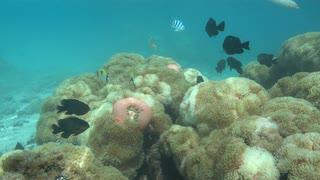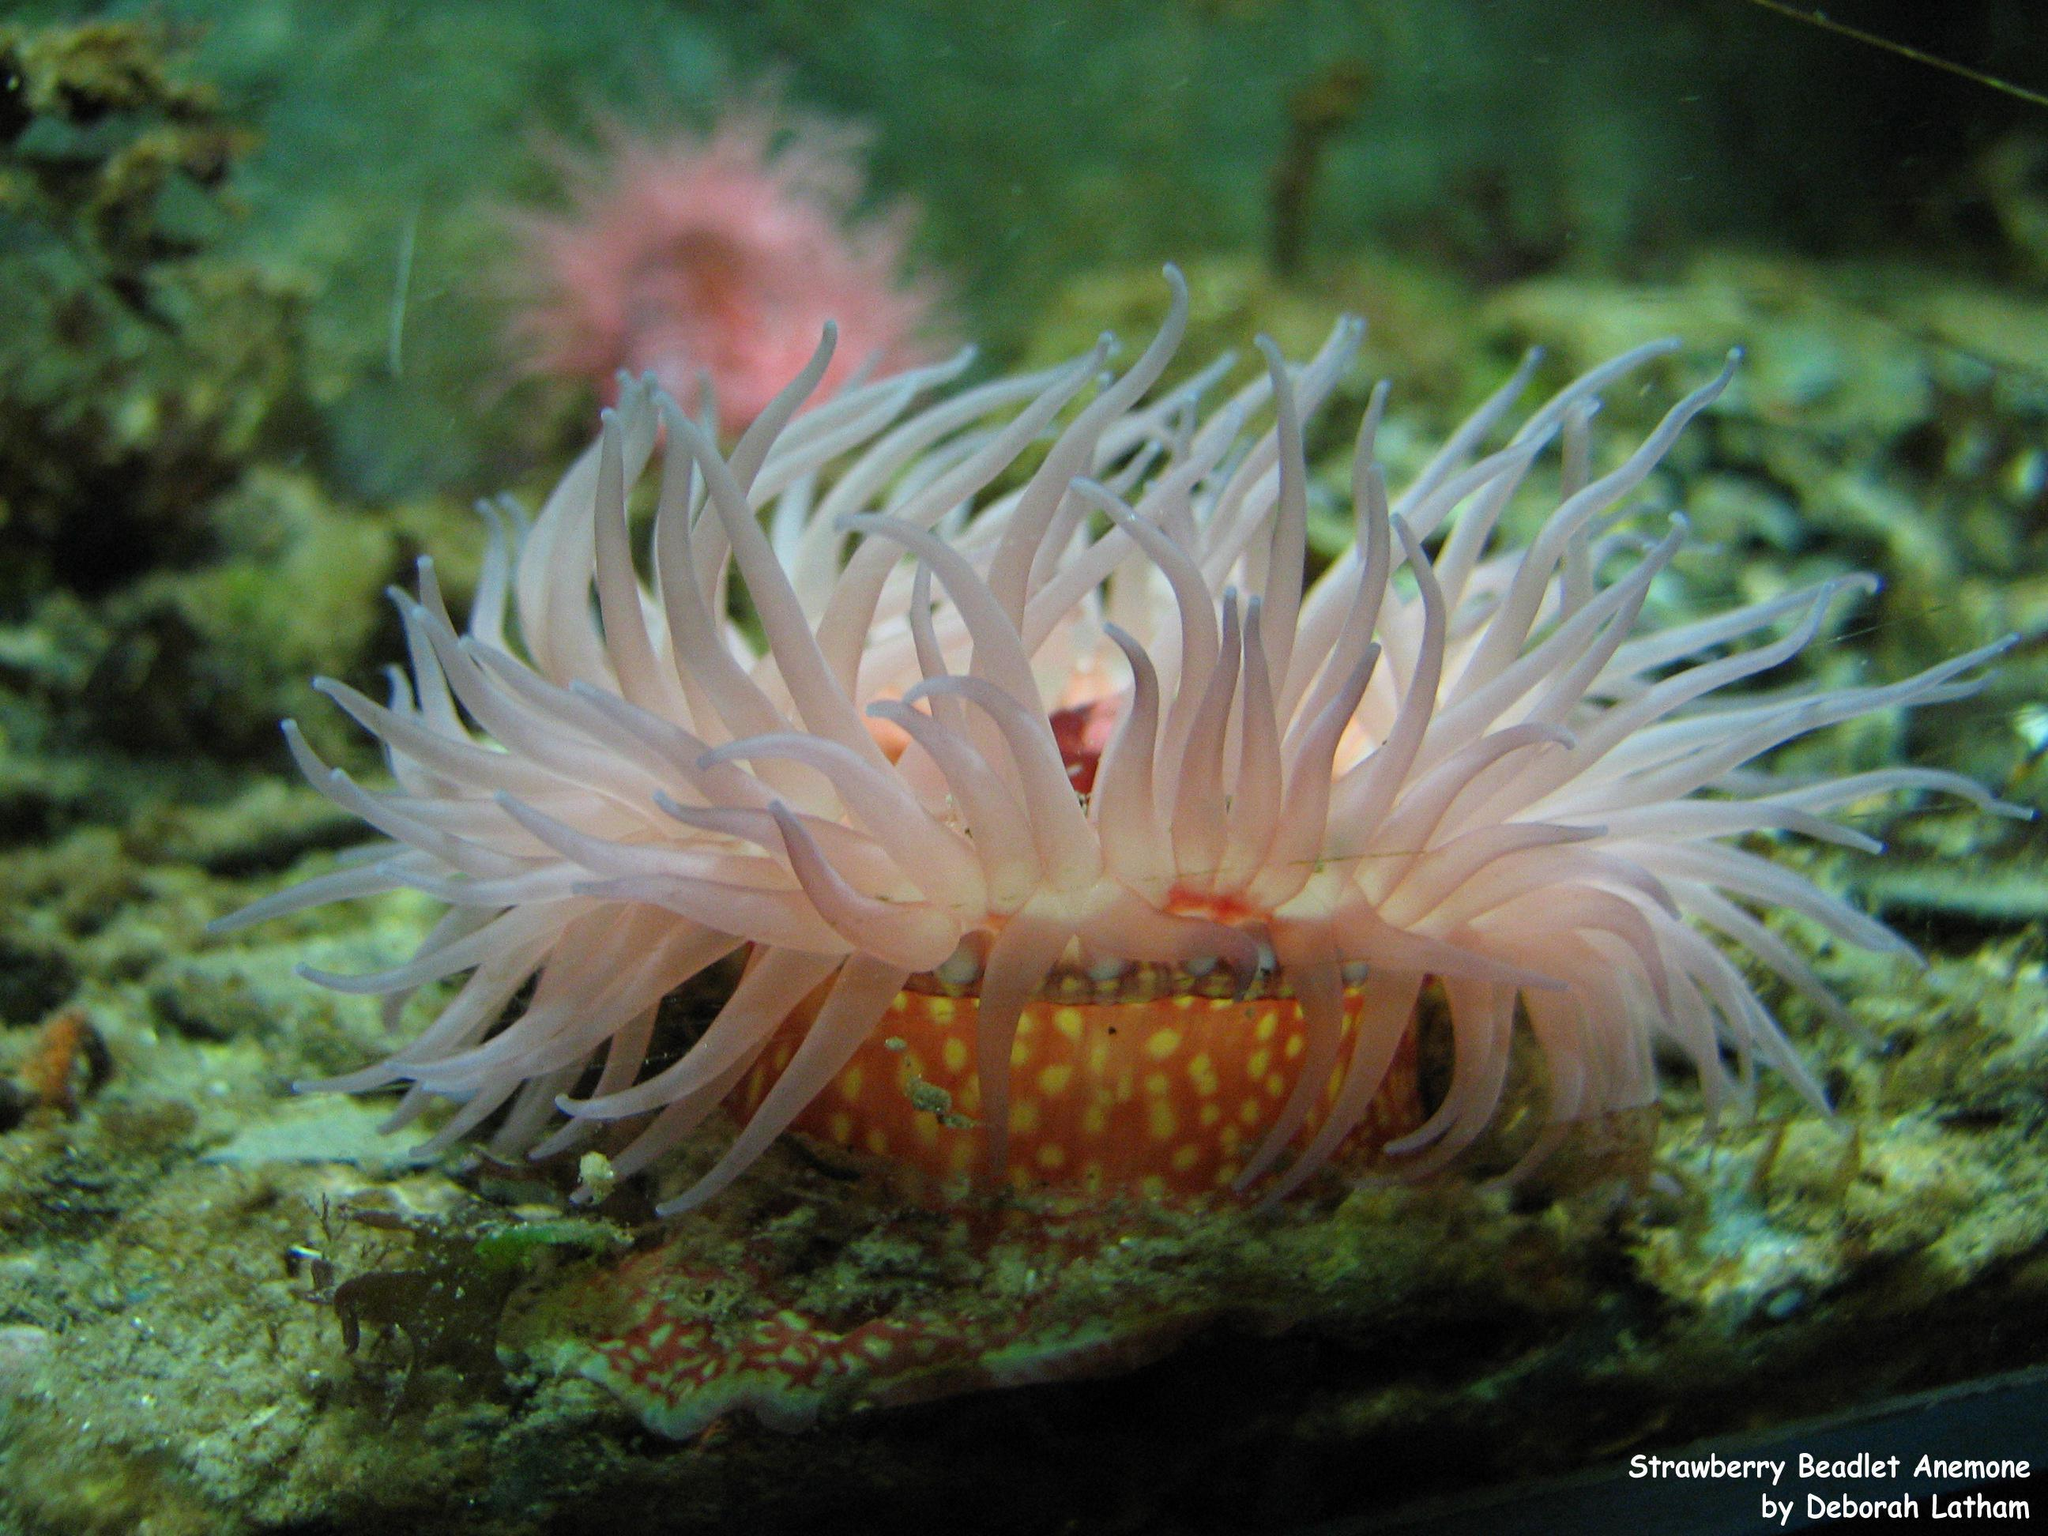The first image is the image on the left, the second image is the image on the right. Given the left and right images, does the statement "there are black fish with a white spot swimming around the reef" hold true? Answer yes or no. No. 